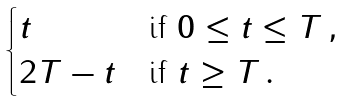<formula> <loc_0><loc_0><loc_500><loc_500>\begin{cases} t & \text {if } 0 \leq t \leq T \, , \\ 2 T - t & \text {if } t \geq T \, . \end{cases}</formula> 